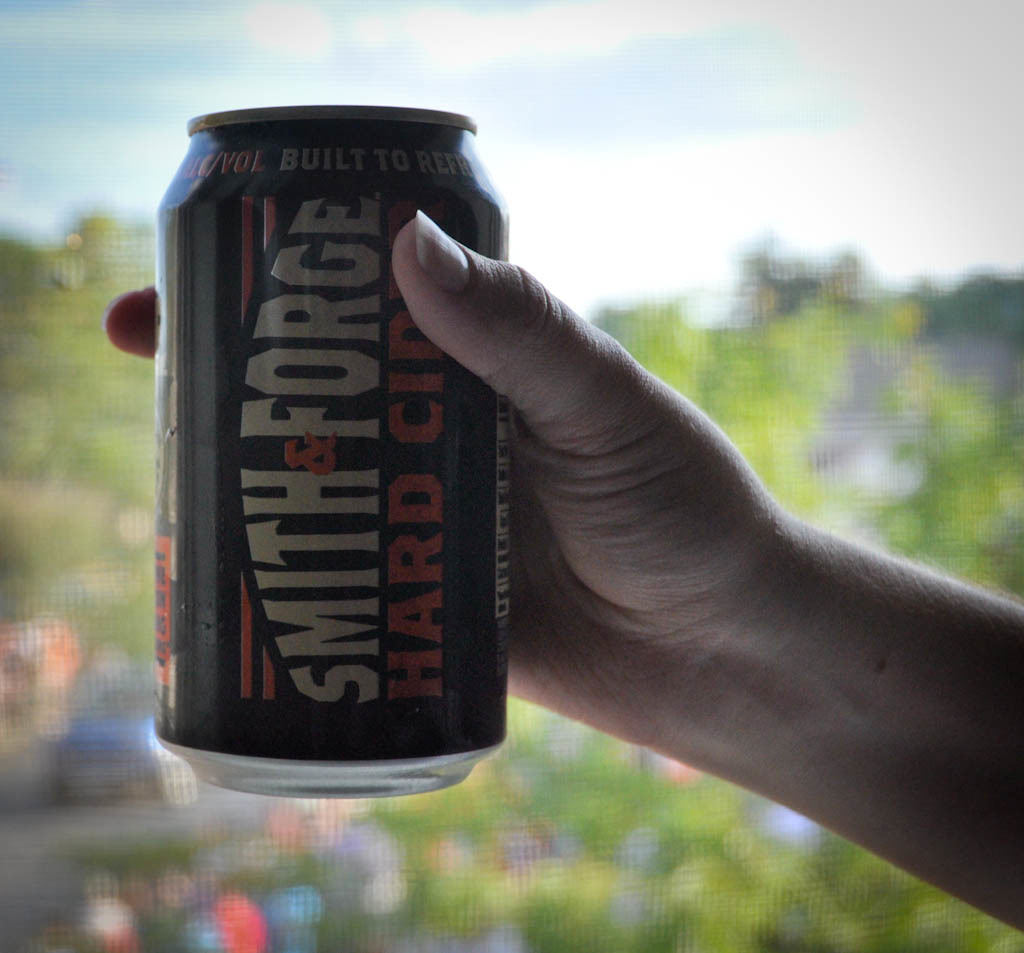Provide a one-sentence caption for the provided image. A hand holds up a can of Smith & Forge hard cider with a focus on the branding and a pleasant, blurred background. 